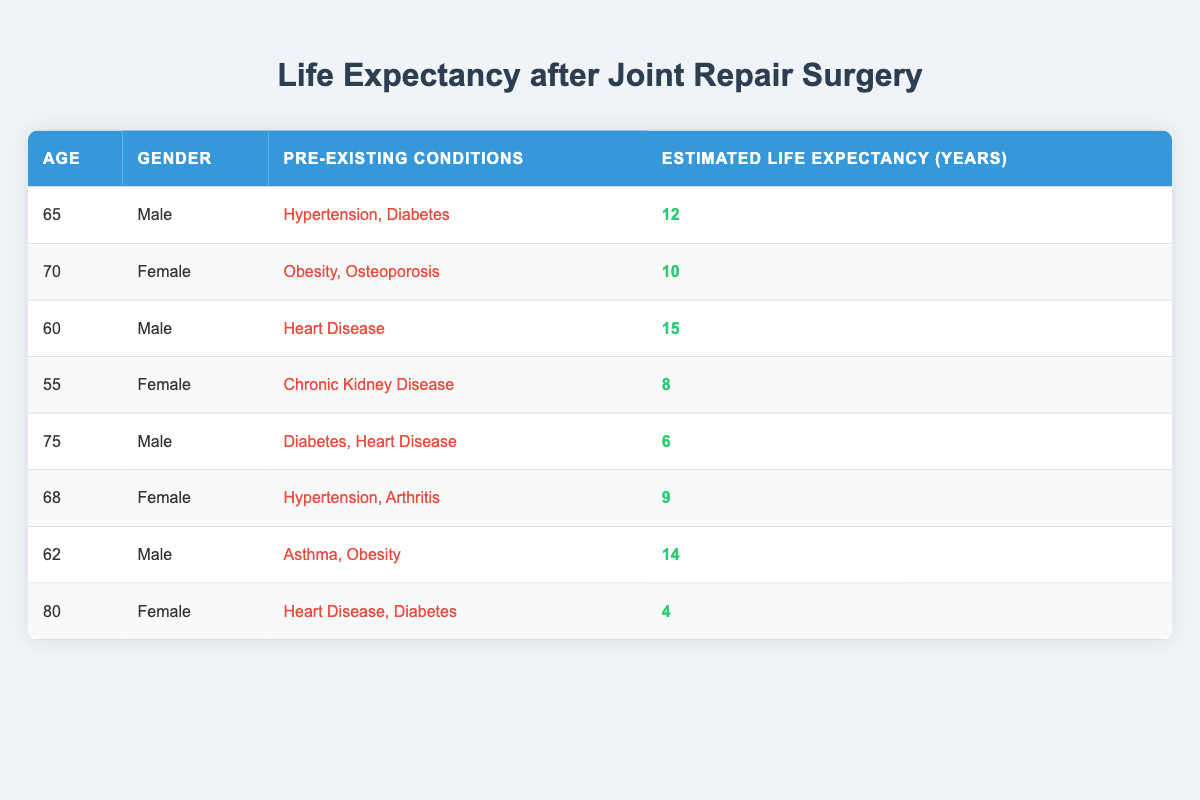What is the estimated life expectancy for a 70-year-old female with obesity and osteoporosis? The table shows that the estimated life expectancy for a 70-year-old female with obesity and osteoporosis is 10 years.
Answer: 10 How many patients in the table are males? By counting the rows in the table, we find 4 males (ages 65, 60, 75, and 62).
Answer: 4 What is the average estimated life expectancy of patients with heart disease? The estimated life expectancy for the patients with heart disease is 15 (age 60), 6 (age 75), and 4 (age 80), which sums up to 25. There are 3 such patients, so the average life expectancy is 25/3 = 8.33 years.
Answer: 8.33 Is the estimated life expectancy of patients with diabetes lower than that of patients without diabetes? Looking at the table, the patients with diabetes have estimated life expectancies of 12 (age 65), 6 (age 75), and 4 (age 80), which gives an average of 7.33 years. For patients without diabetes, the estimated life expectancies are 10 (age 70), 15 (age 60), 8 (age 55), 9 (age 68), and 14 (age 62), giving an average of 12. The comparison shows that the average for those with diabetes is lower (7.33 < 12).
Answer: Yes Which gender has a higher score on estimated life expectancy on average? By calculating the averages, males have estimated life expectancies of (12 + 15 + 6 + 14)/4 = 11.75 and females have (10 + 8 + 9 + 4)/4 = 7.75; hence, males have a higher average.
Answer: Males What is the difference in estimated life expectancy between the youngest and oldest patients in the table? The youngest patient is a 55-year-old female with an estimated life expectancy of 8 years and the oldest patient is an 80-year-old female with an estimated life expectancy of 4 years. The difference in life expectancy is 8 - 4 = 4 years.
Answer: 4 What proportion of patients in the table have chronic kidney disease? There is 1 patient with chronic kidney disease out of a total of 8 patients. Thus, the proportion is 1/8 = 0.125 or 12.5%.
Answer: 12.5% Does any patient in the table have an estimated life expectancy of less than 5 years? Yes, the 80-year-old female patient with heart disease and diabetes has an estimated life expectancy of 4 years.
Answer: Yes 